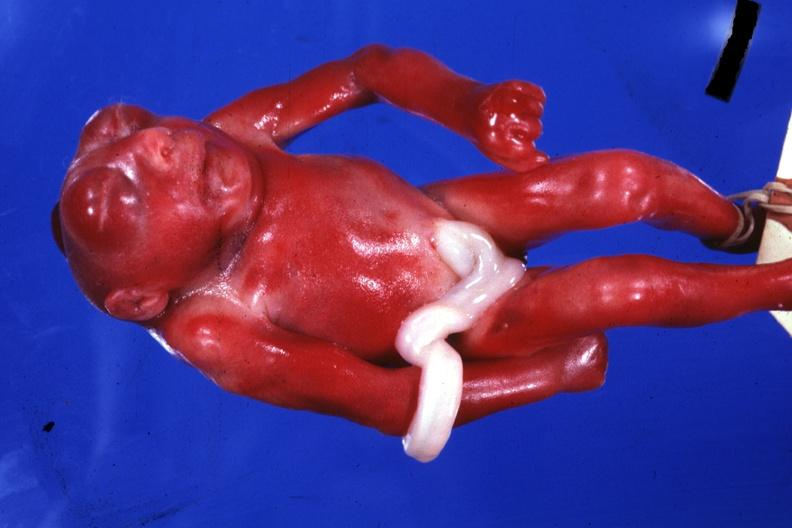what is present?
Answer the question using a single word or phrase. Anencephaly 